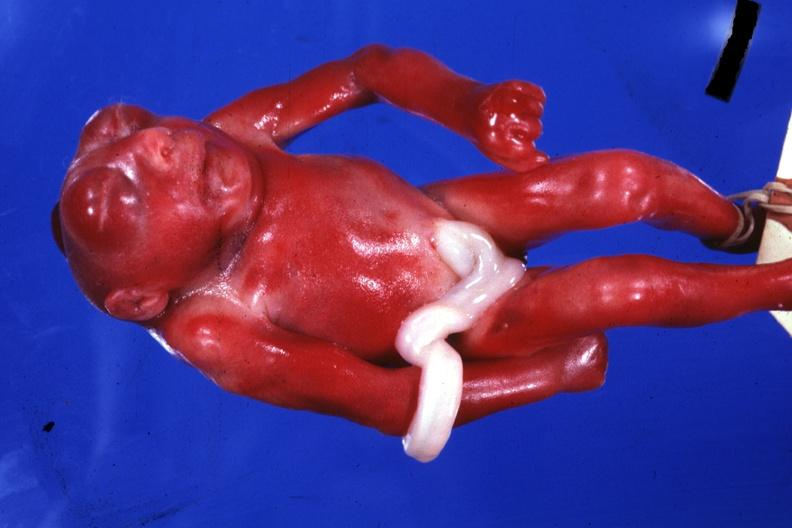what is present?
Answer the question using a single word or phrase. Anencephaly 